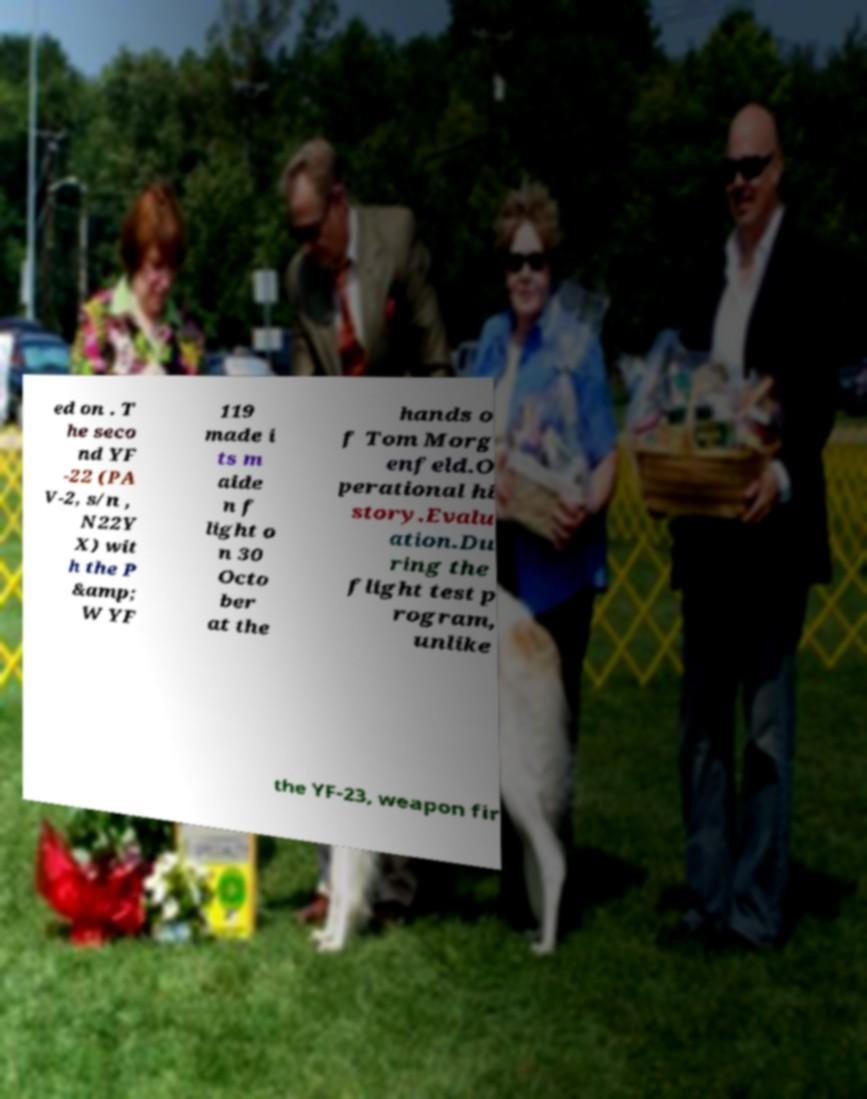For documentation purposes, I need the text within this image transcribed. Could you provide that? ed on . T he seco nd YF -22 (PA V-2, s/n , N22Y X) wit h the P &amp; W YF 119 made i ts m aide n f light o n 30 Octo ber at the hands o f Tom Morg enfeld.O perational hi story.Evalu ation.Du ring the flight test p rogram, unlike the YF-23, weapon fir 